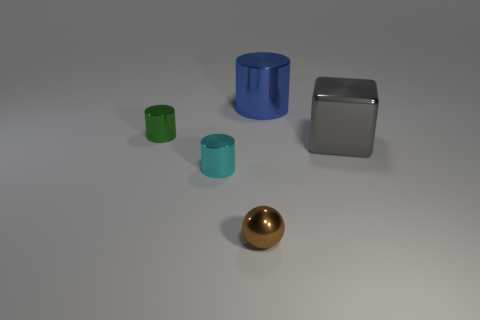What number of metal things are cylinders or small cyan cubes?
Provide a short and direct response. 3. Is the number of tiny brown spheres right of the small green object greater than the number of big blue metallic objects that are left of the blue metallic thing?
Keep it short and to the point. Yes. What number of other objects are the same size as the blue shiny cylinder?
Provide a succinct answer. 1. What is the size of the blue shiny cylinder behind the big metal object on the right side of the big cylinder?
Give a very brief answer. Large. What number of big things are green cylinders or blue shiny cylinders?
Your answer should be compact. 1. There is a shiny cylinder to the right of the small brown thing on the left side of the big thing behind the big gray shiny object; what is its size?
Make the answer very short. Large. Do the green thing and the cyan thing have the same shape?
Keep it short and to the point. Yes. How many objects are in front of the cube and behind the green cylinder?
Provide a succinct answer. 0. There is a small object that is behind the gray cube to the right of the green object; what color is it?
Ensure brevity in your answer.  Green. Is the number of tiny brown metal balls to the right of the blue cylinder the same as the number of green matte cubes?
Give a very brief answer. Yes. 